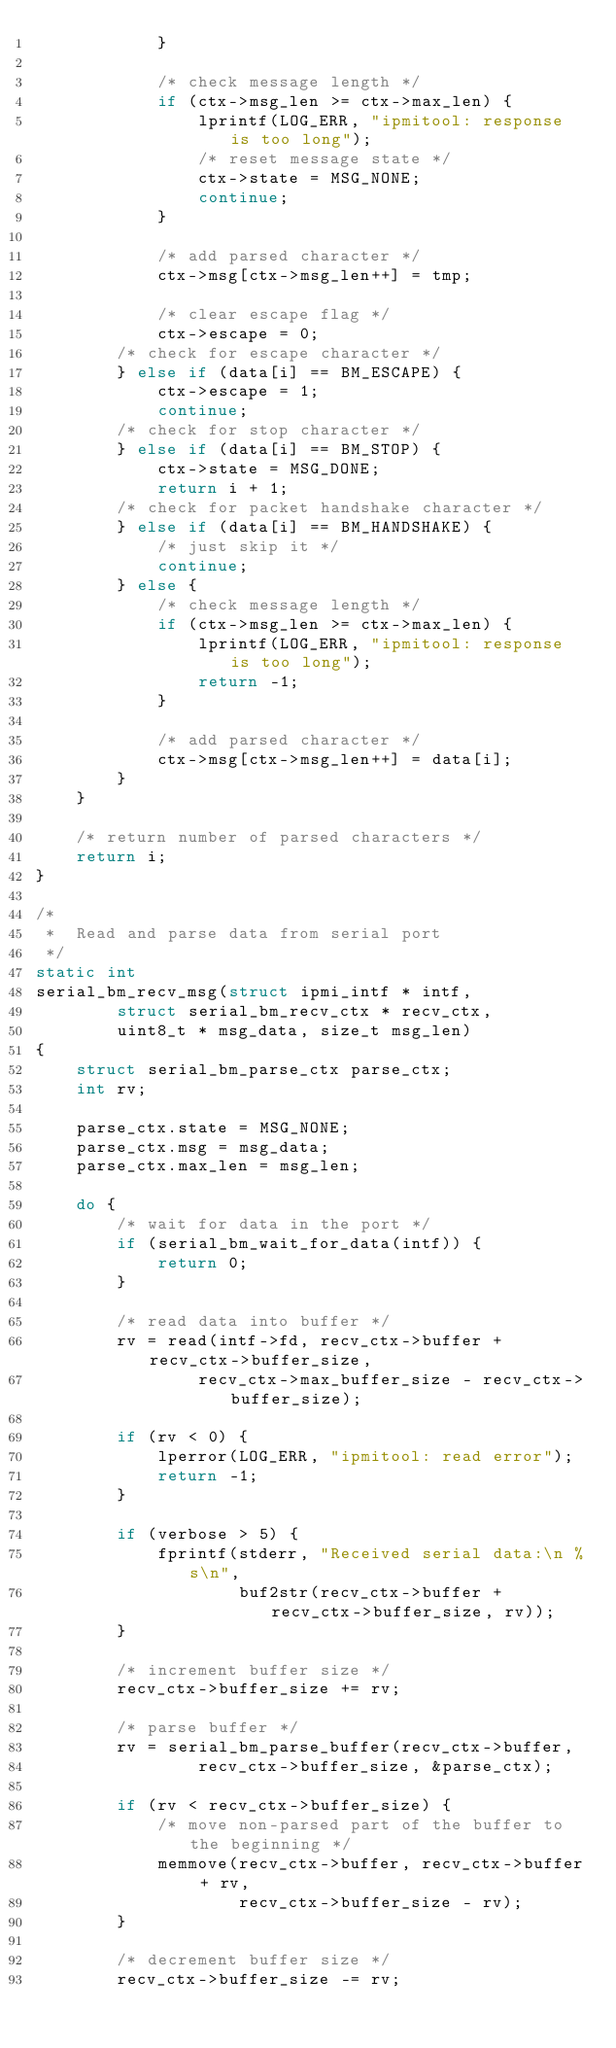<code> <loc_0><loc_0><loc_500><loc_500><_C_>			}

			/* check message length */
			if (ctx->msg_len >= ctx->max_len) {
				lprintf(LOG_ERR, "ipmitool: response is too long");
				/* reset message state */
				ctx->state = MSG_NONE;
				continue;
			}

			/* add parsed character */
			ctx->msg[ctx->msg_len++] = tmp;

			/* clear escape flag */
			ctx->escape = 0;
		/* check for escape character */
		} else if (data[i] == BM_ESCAPE) {
			ctx->escape = 1;
			continue;
		/* check for stop character */
		} else if (data[i] == BM_STOP) {
			ctx->state = MSG_DONE;
			return i + 1;
		/* check for packet handshake character */
		} else if (data[i] == BM_HANDSHAKE) {
			/* just skip it */
			continue;
		} else {
			/* check message length */
			if (ctx->msg_len >= ctx->max_len) {
				lprintf(LOG_ERR, "ipmitool: response is too long");
				return -1;
			}

			/* add parsed character */
			ctx->msg[ctx->msg_len++] = data[i];
		}
	}

	/* return number of parsed characters */
	return i;
}

/*
 *	Read and parse data from serial port
 */
static int
serial_bm_recv_msg(struct ipmi_intf * intf,
		struct serial_bm_recv_ctx * recv_ctx,
		uint8_t * msg_data, size_t msg_len)
{
	struct serial_bm_parse_ctx parse_ctx;
	int rv;

	parse_ctx.state = MSG_NONE;
	parse_ctx.msg = msg_data;
	parse_ctx.max_len = msg_len;

	do {
		/* wait for data in the port */
		if (serial_bm_wait_for_data(intf)) {
			return 0;
		}

		/* read data into buffer */
		rv = read(intf->fd, recv_ctx->buffer + recv_ctx->buffer_size,
				recv_ctx->max_buffer_size - recv_ctx->buffer_size);

		if (rv < 0) {
			lperror(LOG_ERR, "ipmitool: read error");
			return -1;
		}

		if (verbose > 5) {
			fprintf(stderr, "Received serial data:\n %s\n",
					buf2str(recv_ctx->buffer + recv_ctx->buffer_size, rv));
		}

		/* increment buffer size */
		recv_ctx->buffer_size += rv;

		/* parse buffer */
		rv = serial_bm_parse_buffer(recv_ctx->buffer,
				recv_ctx->buffer_size, &parse_ctx);

		if (rv < recv_ctx->buffer_size) {
			/* move non-parsed part of the buffer to the beginning */
			memmove(recv_ctx->buffer, recv_ctx->buffer + rv,
					recv_ctx->buffer_size - rv);
		}

		/* decrement buffer size */
		recv_ctx->buffer_size -= rv;</code> 